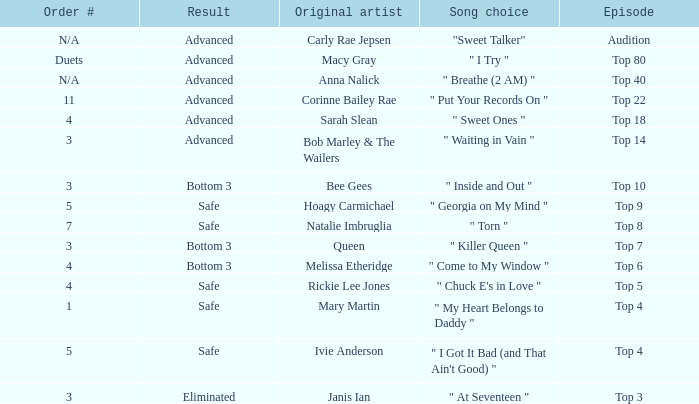What's the original artist of the song performed in the top 3 episode? Janis Ian. 